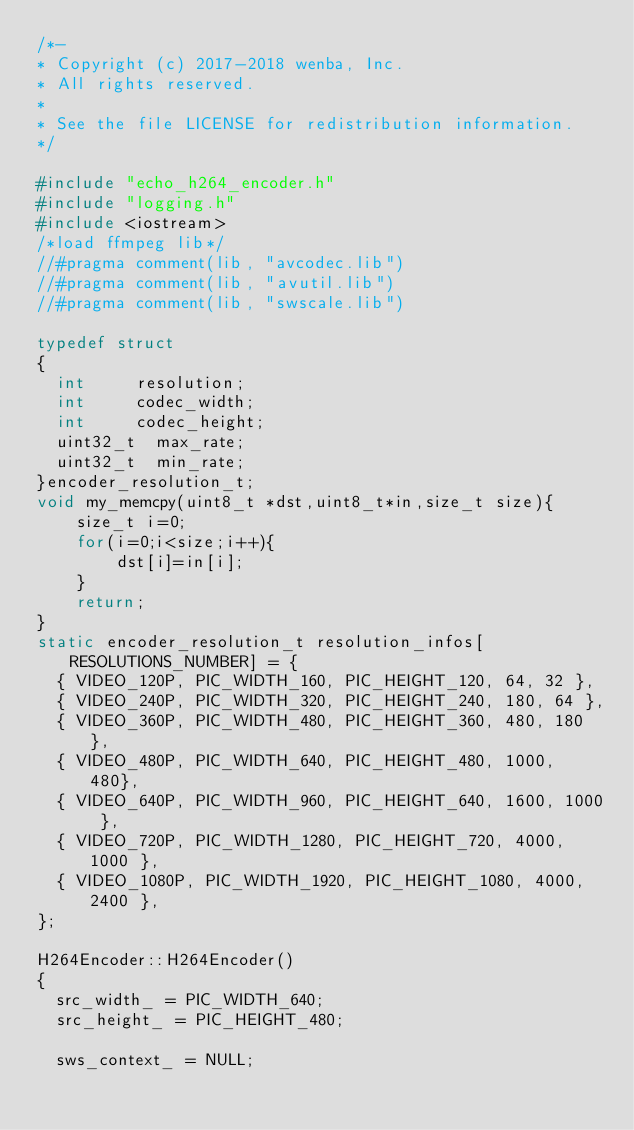Convert code to text. <code><loc_0><loc_0><loc_500><loc_500><_C++_>/*-
* Copyright (c) 2017-2018 wenba, Inc.
*	All rights reserved.
*
* See the file LICENSE for redistribution information.
*/

#include "echo_h264_encoder.h"
#include "logging.h"
#include <iostream>
/*load ffmpeg lib*/
//#pragma comment(lib, "avcodec.lib")
//#pragma comment(lib, "avutil.lib")
//#pragma comment(lib, "swscale.lib")

typedef struct
{
	int			resolution;				
	int			codec_width;			
	int			codec_height;			
	uint32_t	max_rate;				
	uint32_t	min_rate;				
}encoder_resolution_t;
void my_memcpy(uint8_t *dst,uint8_t*in,size_t size){
    size_t i=0;
    for(i=0;i<size;i++){
        dst[i]=in[i];
    }
    return;
}
static encoder_resolution_t resolution_infos[RESOLUTIONS_NUMBER] = {
	{ VIDEO_120P, PIC_WIDTH_160, PIC_HEIGHT_120, 64, 32 },
	{ VIDEO_240P, PIC_WIDTH_320, PIC_HEIGHT_240, 180, 64 },
	{ VIDEO_360P, PIC_WIDTH_480, PIC_HEIGHT_360, 480, 180 },
	{ VIDEO_480P, PIC_WIDTH_640, PIC_HEIGHT_480, 1000, 480},
	{ VIDEO_640P, PIC_WIDTH_960, PIC_HEIGHT_640, 1600, 1000 },
	{ VIDEO_720P, PIC_WIDTH_1280, PIC_HEIGHT_720, 4000, 1000 },
	{ VIDEO_1080P, PIC_WIDTH_1920, PIC_HEIGHT_1080, 4000, 2400 },
};

H264Encoder::H264Encoder()
{
	src_width_ = PIC_WIDTH_640;
	src_height_ = PIC_HEIGHT_480;

	sws_context_ = NULL;
</code> 